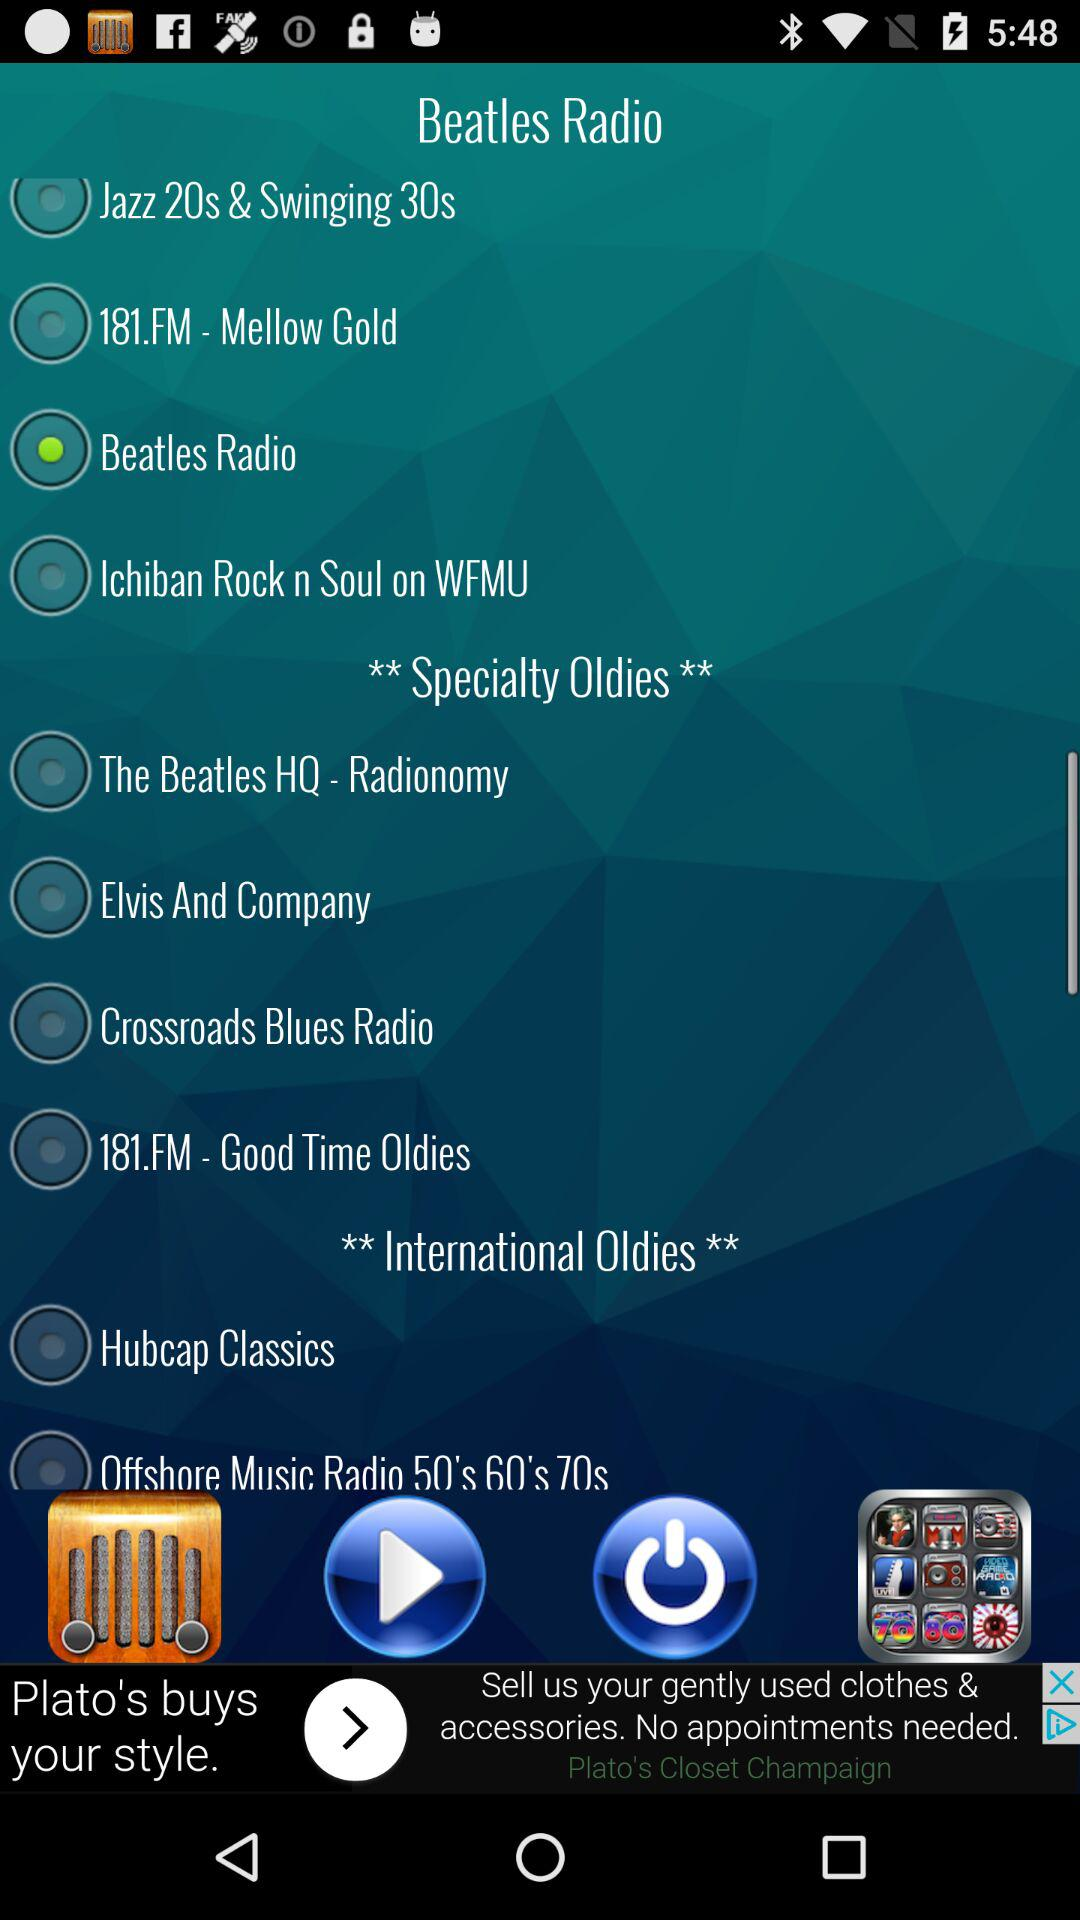Is "Elvis And Company" currently selected or not? "Elvis And Company" is currently not selected. 